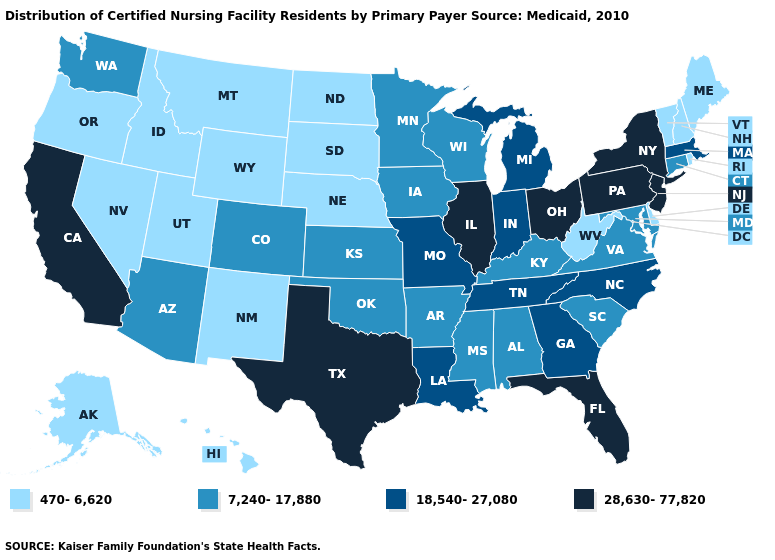Name the states that have a value in the range 470-6,620?
Short answer required. Alaska, Delaware, Hawaii, Idaho, Maine, Montana, Nebraska, Nevada, New Hampshire, New Mexico, North Dakota, Oregon, Rhode Island, South Dakota, Utah, Vermont, West Virginia, Wyoming. Does Nebraska have a lower value than Louisiana?
Answer briefly. Yes. Name the states that have a value in the range 470-6,620?
Concise answer only. Alaska, Delaware, Hawaii, Idaho, Maine, Montana, Nebraska, Nevada, New Hampshire, New Mexico, North Dakota, Oregon, Rhode Island, South Dakota, Utah, Vermont, West Virginia, Wyoming. Name the states that have a value in the range 470-6,620?
Answer briefly. Alaska, Delaware, Hawaii, Idaho, Maine, Montana, Nebraska, Nevada, New Hampshire, New Mexico, North Dakota, Oregon, Rhode Island, South Dakota, Utah, Vermont, West Virginia, Wyoming. Name the states that have a value in the range 28,630-77,820?
Write a very short answer. California, Florida, Illinois, New Jersey, New York, Ohio, Pennsylvania, Texas. Among the states that border Louisiana , does Mississippi have the lowest value?
Be succinct. Yes. What is the value of Wyoming?
Be succinct. 470-6,620. How many symbols are there in the legend?
Write a very short answer. 4. Name the states that have a value in the range 28,630-77,820?
Be succinct. California, Florida, Illinois, New Jersey, New York, Ohio, Pennsylvania, Texas. What is the lowest value in states that border New Hampshire?
Answer briefly. 470-6,620. What is the value of Rhode Island?
Be succinct. 470-6,620. What is the value of Maine?
Keep it brief. 470-6,620. Among the states that border Tennessee , which have the lowest value?
Write a very short answer. Alabama, Arkansas, Kentucky, Mississippi, Virginia. 